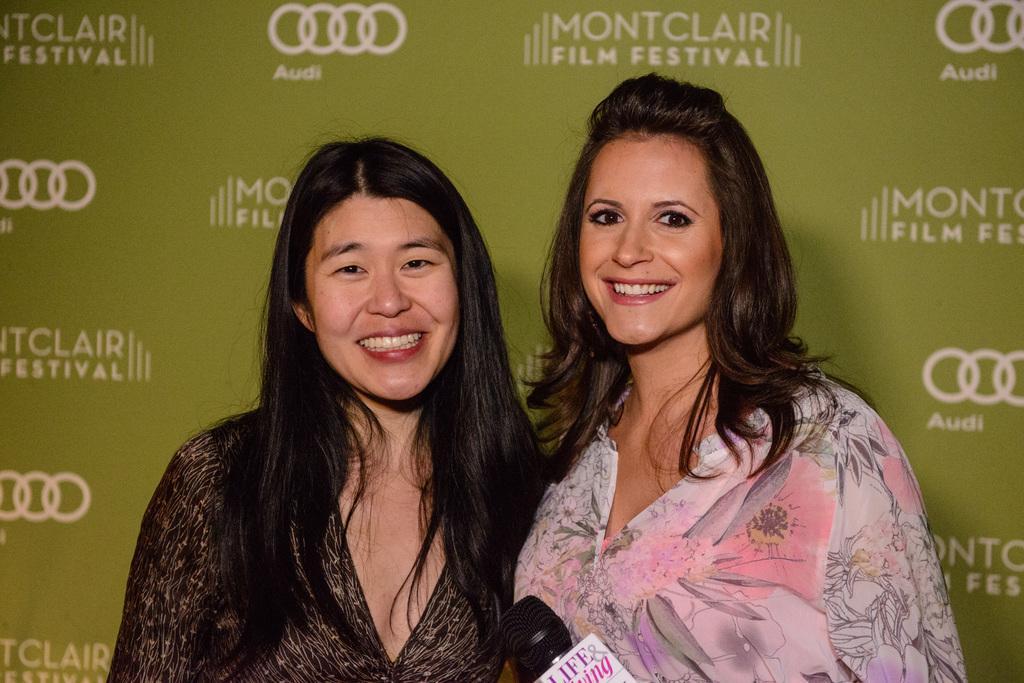In one or two sentences, can you explain what this image depicts? In this image we can see two women standing. On the backside we can see some text. On the bottom of the image we can see a mic. 